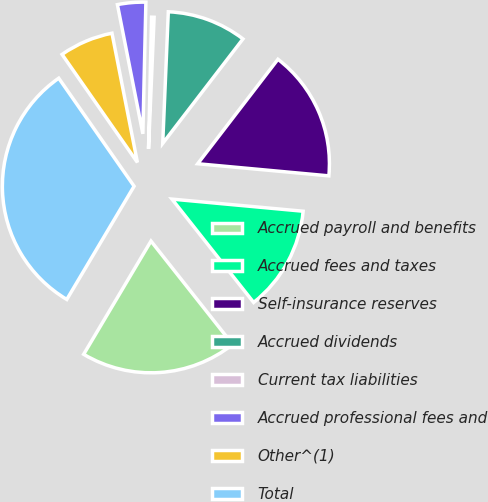Convert chart to OTSL. <chart><loc_0><loc_0><loc_500><loc_500><pie_chart><fcel>Accrued payroll and benefits<fcel>Accrued fees and taxes<fcel>Self-insurance reserves<fcel>Accrued dividends<fcel>Current tax liabilities<fcel>Accrued professional fees and<fcel>Other^(1)<fcel>Total<nl><fcel>19.18%<fcel>12.89%<fcel>16.04%<fcel>9.75%<fcel>0.31%<fcel>3.46%<fcel>6.6%<fcel>31.77%<nl></chart> 